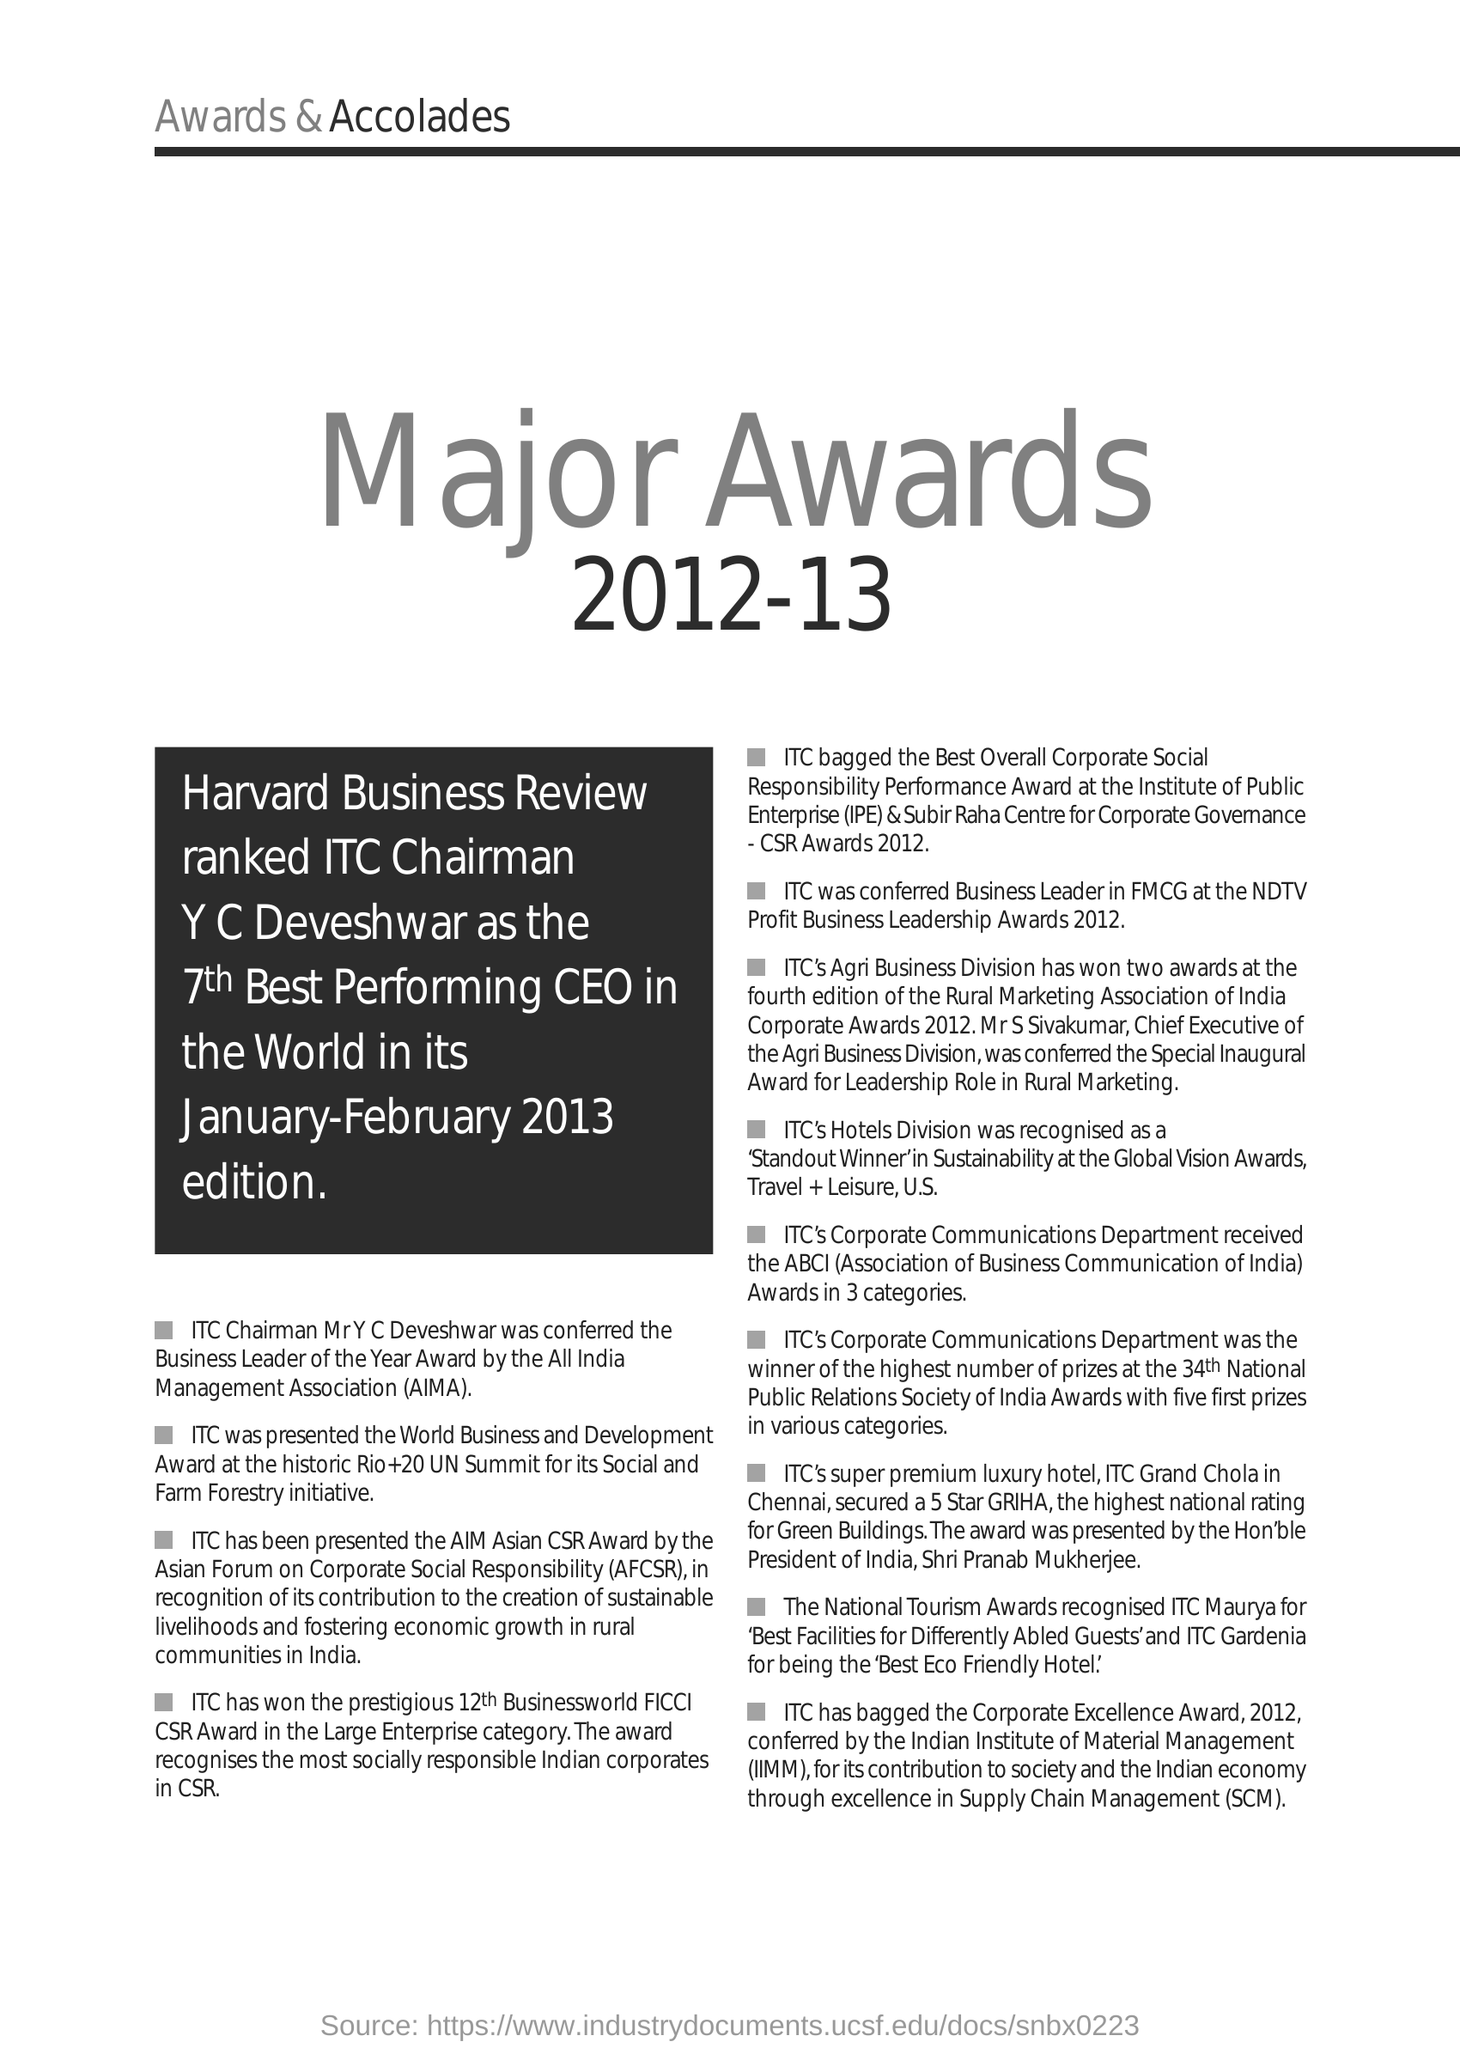What is the Fullform of SCM ?
Provide a short and direct response. Supply chain Management. What is the Fullform of IIMM ?
Your answer should be compact. Indian Institute of Material Management (IIMM). What is the Fullform of IPE ?
Make the answer very short. Institute of Public Enterprise (IPE). What is the Fullform of AIMA ?
Offer a terse response. All India Management Association (AIMA). What is the Fullform of AFCSR ?
Your answer should be very brief. Asian Forum on Corporate Social Responsibility (AFCSR). What is the Fullform of ABCI ?
Your answer should be very brief. ABCI (Association of Business Communication of India). 